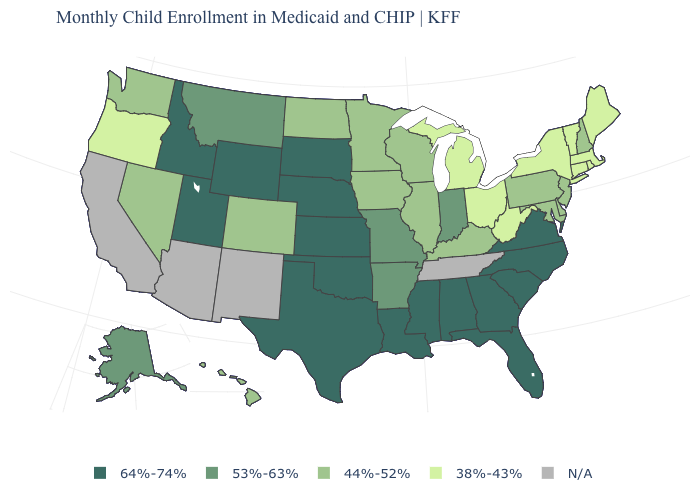Does South Dakota have the highest value in the MidWest?
Quick response, please. Yes. Is the legend a continuous bar?
Write a very short answer. No. Does the first symbol in the legend represent the smallest category?
Write a very short answer. No. How many symbols are there in the legend?
Keep it brief. 5. Does Colorado have the highest value in the West?
Write a very short answer. No. Which states have the lowest value in the USA?
Concise answer only. Connecticut, Maine, Massachusetts, Michigan, New York, Ohio, Oregon, Rhode Island, Vermont, West Virginia. Which states have the highest value in the USA?
Short answer required. Alabama, Florida, Georgia, Idaho, Kansas, Louisiana, Mississippi, Nebraska, North Carolina, Oklahoma, South Carolina, South Dakota, Texas, Utah, Virginia, Wyoming. Name the states that have a value in the range 53%-63%?
Be succinct. Alaska, Arkansas, Indiana, Missouri, Montana. Name the states that have a value in the range N/A?
Give a very brief answer. Arizona, California, New Mexico, Tennessee. Name the states that have a value in the range 53%-63%?
Write a very short answer. Alaska, Arkansas, Indiana, Missouri, Montana. What is the value of Montana?
Give a very brief answer. 53%-63%. Which states have the lowest value in the USA?
Quick response, please. Connecticut, Maine, Massachusetts, Michigan, New York, Ohio, Oregon, Rhode Island, Vermont, West Virginia. Name the states that have a value in the range N/A?
Write a very short answer. Arizona, California, New Mexico, Tennessee. Which states hav the highest value in the West?
Write a very short answer. Idaho, Utah, Wyoming. Does Oklahoma have the lowest value in the USA?
Concise answer only. No. 